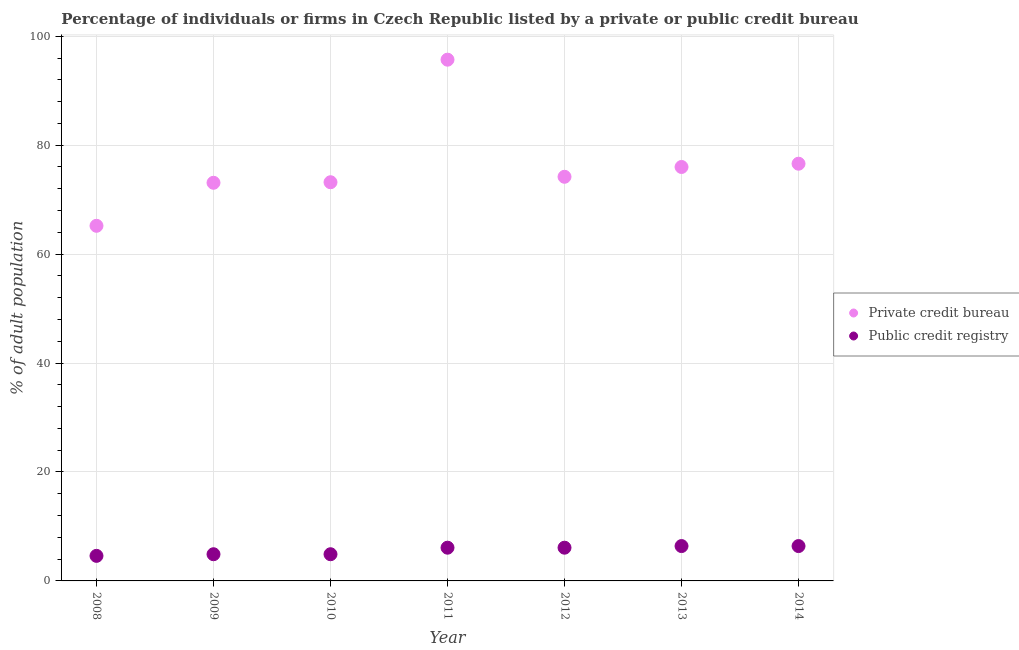What is the percentage of firms listed by public credit bureau in 2013?
Your answer should be compact. 6.4. Across all years, what is the maximum percentage of firms listed by public credit bureau?
Offer a very short reply. 6.4. Across all years, what is the minimum percentage of firms listed by private credit bureau?
Provide a succinct answer. 65.2. In which year was the percentage of firms listed by private credit bureau maximum?
Ensure brevity in your answer.  2011. In which year was the percentage of firms listed by private credit bureau minimum?
Keep it short and to the point. 2008. What is the total percentage of firms listed by public credit bureau in the graph?
Keep it short and to the point. 39.4. What is the difference between the percentage of firms listed by private credit bureau in 2008 and that in 2009?
Make the answer very short. -7.9. What is the difference between the percentage of firms listed by private credit bureau in 2014 and the percentage of firms listed by public credit bureau in 2013?
Provide a succinct answer. 70.2. What is the average percentage of firms listed by public credit bureau per year?
Offer a very short reply. 5.63. In the year 2011, what is the difference between the percentage of firms listed by public credit bureau and percentage of firms listed by private credit bureau?
Give a very brief answer. -89.6. What is the ratio of the percentage of firms listed by public credit bureau in 2009 to that in 2013?
Make the answer very short. 0.77. Is the difference between the percentage of firms listed by private credit bureau in 2009 and 2014 greater than the difference between the percentage of firms listed by public credit bureau in 2009 and 2014?
Offer a terse response. No. What is the difference between the highest and the second highest percentage of firms listed by private credit bureau?
Offer a terse response. 19.1. What is the difference between the highest and the lowest percentage of firms listed by public credit bureau?
Your response must be concise. 1.8. In how many years, is the percentage of firms listed by public credit bureau greater than the average percentage of firms listed by public credit bureau taken over all years?
Offer a terse response. 4. Does the percentage of firms listed by public credit bureau monotonically increase over the years?
Give a very brief answer. No. Is the percentage of firms listed by private credit bureau strictly less than the percentage of firms listed by public credit bureau over the years?
Make the answer very short. No. How many years are there in the graph?
Offer a terse response. 7. Are the values on the major ticks of Y-axis written in scientific E-notation?
Provide a succinct answer. No. Does the graph contain any zero values?
Offer a terse response. No. How many legend labels are there?
Your answer should be very brief. 2. How are the legend labels stacked?
Keep it short and to the point. Vertical. What is the title of the graph?
Your answer should be very brief. Percentage of individuals or firms in Czech Republic listed by a private or public credit bureau. Does "Investment in Transport" appear as one of the legend labels in the graph?
Your answer should be very brief. No. What is the label or title of the X-axis?
Give a very brief answer. Year. What is the label or title of the Y-axis?
Offer a very short reply. % of adult population. What is the % of adult population of Private credit bureau in 2008?
Your answer should be compact. 65.2. What is the % of adult population in Public credit registry in 2008?
Offer a very short reply. 4.6. What is the % of adult population in Private credit bureau in 2009?
Your answer should be very brief. 73.1. What is the % of adult population of Private credit bureau in 2010?
Keep it short and to the point. 73.2. What is the % of adult population in Private credit bureau in 2011?
Give a very brief answer. 95.7. What is the % of adult population in Public credit registry in 2011?
Provide a succinct answer. 6.1. What is the % of adult population of Private credit bureau in 2012?
Your answer should be compact. 74.2. What is the % of adult population in Private credit bureau in 2013?
Your answer should be compact. 76. What is the % of adult population of Public credit registry in 2013?
Provide a succinct answer. 6.4. What is the % of adult population of Private credit bureau in 2014?
Your response must be concise. 76.6. What is the % of adult population of Public credit registry in 2014?
Give a very brief answer. 6.4. Across all years, what is the maximum % of adult population in Private credit bureau?
Keep it short and to the point. 95.7. Across all years, what is the maximum % of adult population in Public credit registry?
Keep it short and to the point. 6.4. Across all years, what is the minimum % of adult population in Private credit bureau?
Provide a succinct answer. 65.2. Across all years, what is the minimum % of adult population in Public credit registry?
Ensure brevity in your answer.  4.6. What is the total % of adult population in Private credit bureau in the graph?
Your answer should be very brief. 534. What is the total % of adult population in Public credit registry in the graph?
Your response must be concise. 39.4. What is the difference between the % of adult population of Private credit bureau in 2008 and that in 2010?
Provide a succinct answer. -8. What is the difference between the % of adult population in Private credit bureau in 2008 and that in 2011?
Make the answer very short. -30.5. What is the difference between the % of adult population of Public credit registry in 2008 and that in 2014?
Provide a short and direct response. -1.8. What is the difference between the % of adult population of Public credit registry in 2009 and that in 2010?
Offer a very short reply. 0. What is the difference between the % of adult population of Private credit bureau in 2009 and that in 2011?
Ensure brevity in your answer.  -22.6. What is the difference between the % of adult population in Public credit registry in 2009 and that in 2012?
Make the answer very short. -1.2. What is the difference between the % of adult population of Private credit bureau in 2009 and that in 2014?
Make the answer very short. -3.5. What is the difference between the % of adult population of Public credit registry in 2009 and that in 2014?
Your response must be concise. -1.5. What is the difference between the % of adult population of Private credit bureau in 2010 and that in 2011?
Provide a succinct answer. -22.5. What is the difference between the % of adult population of Private credit bureau in 2010 and that in 2012?
Offer a very short reply. -1. What is the difference between the % of adult population in Public credit registry in 2010 and that in 2012?
Your answer should be very brief. -1.2. What is the difference between the % of adult population of Private credit bureau in 2010 and that in 2013?
Make the answer very short. -2.8. What is the difference between the % of adult population of Public credit registry in 2010 and that in 2013?
Keep it short and to the point. -1.5. What is the difference between the % of adult population in Private credit bureau in 2010 and that in 2014?
Make the answer very short. -3.4. What is the difference between the % of adult population of Public credit registry in 2010 and that in 2014?
Offer a very short reply. -1.5. What is the difference between the % of adult population in Private credit bureau in 2011 and that in 2012?
Give a very brief answer. 21.5. What is the difference between the % of adult population of Public credit registry in 2011 and that in 2012?
Your answer should be very brief. 0. What is the difference between the % of adult population in Public credit registry in 2011 and that in 2013?
Your answer should be very brief. -0.3. What is the difference between the % of adult population in Private credit bureau in 2012 and that in 2013?
Your answer should be compact. -1.8. What is the difference between the % of adult population of Private credit bureau in 2012 and that in 2014?
Your answer should be compact. -2.4. What is the difference between the % of adult population of Public credit registry in 2013 and that in 2014?
Offer a terse response. 0. What is the difference between the % of adult population in Private credit bureau in 2008 and the % of adult population in Public credit registry in 2009?
Provide a short and direct response. 60.3. What is the difference between the % of adult population of Private credit bureau in 2008 and the % of adult population of Public credit registry in 2010?
Offer a terse response. 60.3. What is the difference between the % of adult population in Private credit bureau in 2008 and the % of adult population in Public credit registry in 2011?
Your answer should be compact. 59.1. What is the difference between the % of adult population in Private credit bureau in 2008 and the % of adult population in Public credit registry in 2012?
Provide a short and direct response. 59.1. What is the difference between the % of adult population of Private credit bureau in 2008 and the % of adult population of Public credit registry in 2013?
Your answer should be very brief. 58.8. What is the difference between the % of adult population of Private credit bureau in 2008 and the % of adult population of Public credit registry in 2014?
Provide a short and direct response. 58.8. What is the difference between the % of adult population in Private credit bureau in 2009 and the % of adult population in Public credit registry in 2010?
Provide a succinct answer. 68.2. What is the difference between the % of adult population of Private credit bureau in 2009 and the % of adult population of Public credit registry in 2011?
Your answer should be very brief. 67. What is the difference between the % of adult population in Private credit bureau in 2009 and the % of adult population in Public credit registry in 2013?
Give a very brief answer. 66.7. What is the difference between the % of adult population of Private credit bureau in 2009 and the % of adult population of Public credit registry in 2014?
Provide a succinct answer. 66.7. What is the difference between the % of adult population in Private credit bureau in 2010 and the % of adult population in Public credit registry in 2011?
Offer a terse response. 67.1. What is the difference between the % of adult population of Private credit bureau in 2010 and the % of adult population of Public credit registry in 2012?
Your answer should be very brief. 67.1. What is the difference between the % of adult population in Private credit bureau in 2010 and the % of adult population in Public credit registry in 2013?
Offer a very short reply. 66.8. What is the difference between the % of adult population in Private credit bureau in 2010 and the % of adult population in Public credit registry in 2014?
Give a very brief answer. 66.8. What is the difference between the % of adult population in Private credit bureau in 2011 and the % of adult population in Public credit registry in 2012?
Provide a succinct answer. 89.6. What is the difference between the % of adult population in Private credit bureau in 2011 and the % of adult population in Public credit registry in 2013?
Ensure brevity in your answer.  89.3. What is the difference between the % of adult population in Private credit bureau in 2011 and the % of adult population in Public credit registry in 2014?
Make the answer very short. 89.3. What is the difference between the % of adult population in Private credit bureau in 2012 and the % of adult population in Public credit registry in 2013?
Your answer should be compact. 67.8. What is the difference between the % of adult population in Private credit bureau in 2012 and the % of adult population in Public credit registry in 2014?
Give a very brief answer. 67.8. What is the difference between the % of adult population in Private credit bureau in 2013 and the % of adult population in Public credit registry in 2014?
Offer a very short reply. 69.6. What is the average % of adult population in Private credit bureau per year?
Provide a short and direct response. 76.29. What is the average % of adult population in Public credit registry per year?
Provide a short and direct response. 5.63. In the year 2008, what is the difference between the % of adult population of Private credit bureau and % of adult population of Public credit registry?
Provide a short and direct response. 60.6. In the year 2009, what is the difference between the % of adult population of Private credit bureau and % of adult population of Public credit registry?
Your answer should be very brief. 68.2. In the year 2010, what is the difference between the % of adult population of Private credit bureau and % of adult population of Public credit registry?
Offer a very short reply. 68.3. In the year 2011, what is the difference between the % of adult population in Private credit bureau and % of adult population in Public credit registry?
Provide a succinct answer. 89.6. In the year 2012, what is the difference between the % of adult population in Private credit bureau and % of adult population in Public credit registry?
Your response must be concise. 68.1. In the year 2013, what is the difference between the % of adult population in Private credit bureau and % of adult population in Public credit registry?
Provide a succinct answer. 69.6. In the year 2014, what is the difference between the % of adult population of Private credit bureau and % of adult population of Public credit registry?
Keep it short and to the point. 70.2. What is the ratio of the % of adult population in Private credit bureau in 2008 to that in 2009?
Offer a very short reply. 0.89. What is the ratio of the % of adult population in Public credit registry in 2008 to that in 2009?
Your answer should be compact. 0.94. What is the ratio of the % of adult population of Private credit bureau in 2008 to that in 2010?
Offer a very short reply. 0.89. What is the ratio of the % of adult population in Public credit registry in 2008 to that in 2010?
Keep it short and to the point. 0.94. What is the ratio of the % of adult population in Private credit bureau in 2008 to that in 2011?
Your answer should be very brief. 0.68. What is the ratio of the % of adult population of Public credit registry in 2008 to that in 2011?
Your answer should be very brief. 0.75. What is the ratio of the % of adult population of Private credit bureau in 2008 to that in 2012?
Offer a very short reply. 0.88. What is the ratio of the % of adult population of Public credit registry in 2008 to that in 2012?
Provide a short and direct response. 0.75. What is the ratio of the % of adult population in Private credit bureau in 2008 to that in 2013?
Ensure brevity in your answer.  0.86. What is the ratio of the % of adult population of Public credit registry in 2008 to that in 2013?
Give a very brief answer. 0.72. What is the ratio of the % of adult population of Private credit bureau in 2008 to that in 2014?
Keep it short and to the point. 0.85. What is the ratio of the % of adult population in Public credit registry in 2008 to that in 2014?
Keep it short and to the point. 0.72. What is the ratio of the % of adult population in Private credit bureau in 2009 to that in 2010?
Make the answer very short. 1. What is the ratio of the % of adult population of Private credit bureau in 2009 to that in 2011?
Your answer should be very brief. 0.76. What is the ratio of the % of adult population in Public credit registry in 2009 to that in 2011?
Offer a terse response. 0.8. What is the ratio of the % of adult population in Private credit bureau in 2009 to that in 2012?
Your answer should be very brief. 0.99. What is the ratio of the % of adult population in Public credit registry in 2009 to that in 2012?
Give a very brief answer. 0.8. What is the ratio of the % of adult population of Private credit bureau in 2009 to that in 2013?
Keep it short and to the point. 0.96. What is the ratio of the % of adult population of Public credit registry in 2009 to that in 2013?
Ensure brevity in your answer.  0.77. What is the ratio of the % of adult population in Private credit bureau in 2009 to that in 2014?
Offer a terse response. 0.95. What is the ratio of the % of adult population of Public credit registry in 2009 to that in 2014?
Your answer should be compact. 0.77. What is the ratio of the % of adult population of Private credit bureau in 2010 to that in 2011?
Give a very brief answer. 0.76. What is the ratio of the % of adult population in Public credit registry in 2010 to that in 2011?
Your answer should be very brief. 0.8. What is the ratio of the % of adult population in Private credit bureau in 2010 to that in 2012?
Your answer should be compact. 0.99. What is the ratio of the % of adult population in Public credit registry in 2010 to that in 2012?
Make the answer very short. 0.8. What is the ratio of the % of adult population of Private credit bureau in 2010 to that in 2013?
Ensure brevity in your answer.  0.96. What is the ratio of the % of adult population of Public credit registry in 2010 to that in 2013?
Keep it short and to the point. 0.77. What is the ratio of the % of adult population in Private credit bureau in 2010 to that in 2014?
Your answer should be compact. 0.96. What is the ratio of the % of adult population in Public credit registry in 2010 to that in 2014?
Ensure brevity in your answer.  0.77. What is the ratio of the % of adult population in Private credit bureau in 2011 to that in 2012?
Your response must be concise. 1.29. What is the ratio of the % of adult population of Private credit bureau in 2011 to that in 2013?
Offer a very short reply. 1.26. What is the ratio of the % of adult population of Public credit registry in 2011 to that in 2013?
Your response must be concise. 0.95. What is the ratio of the % of adult population in Private credit bureau in 2011 to that in 2014?
Make the answer very short. 1.25. What is the ratio of the % of adult population in Public credit registry in 2011 to that in 2014?
Provide a short and direct response. 0.95. What is the ratio of the % of adult population in Private credit bureau in 2012 to that in 2013?
Your response must be concise. 0.98. What is the ratio of the % of adult population of Public credit registry in 2012 to that in 2013?
Give a very brief answer. 0.95. What is the ratio of the % of adult population in Private credit bureau in 2012 to that in 2014?
Provide a succinct answer. 0.97. What is the ratio of the % of adult population in Public credit registry in 2012 to that in 2014?
Make the answer very short. 0.95. What is the ratio of the % of adult population of Public credit registry in 2013 to that in 2014?
Your response must be concise. 1. What is the difference between the highest and the second highest % of adult population in Private credit bureau?
Give a very brief answer. 19.1. What is the difference between the highest and the lowest % of adult population of Private credit bureau?
Keep it short and to the point. 30.5. What is the difference between the highest and the lowest % of adult population in Public credit registry?
Provide a succinct answer. 1.8. 